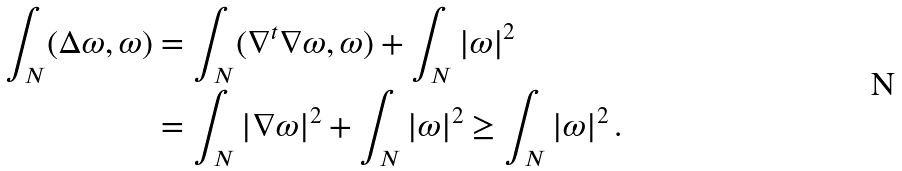<formula> <loc_0><loc_0><loc_500><loc_500>\int _ { N } ( \Delta \omega , \omega ) & = \int _ { N } ( \nabla ^ { t } \nabla \omega , \omega ) + \int _ { N } | \omega | ^ { 2 } \\ & = \int _ { N } | \nabla \omega | ^ { 2 } + \int _ { N } | \omega | ^ { 2 } \geq \int _ { N } | \omega | ^ { 2 } \, .</formula> 